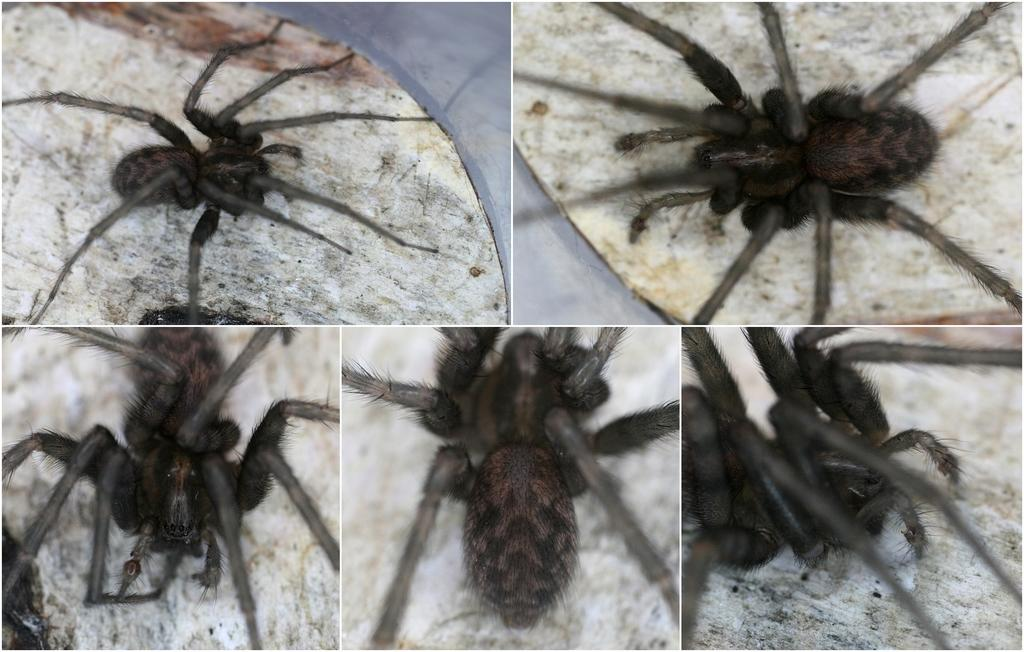What type of image is being described? The image is a collage. What is one of the elements in the collage? There is a spider in the image. Where is the spider located within the collage? The spider is on a surface. What type of art is the spider suggesting in the image? There is no indication in the image that the spider is suggesting any type of art. 